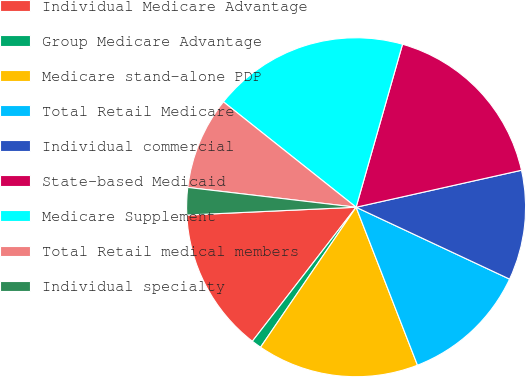Convert chart to OTSL. <chart><loc_0><loc_0><loc_500><loc_500><pie_chart><fcel>Individual Medicare Advantage<fcel>Group Medicare Advantage<fcel>Medicare stand-alone PDP<fcel>Total Retail Medicare<fcel>Individual commercial<fcel>State-based Medicaid<fcel>Medicare Supplement<fcel>Total Retail medical members<fcel>Individual specialty<nl><fcel>13.78%<fcel>0.95%<fcel>15.43%<fcel>12.13%<fcel>10.47%<fcel>17.08%<fcel>18.73%<fcel>8.82%<fcel>2.6%<nl></chart> 